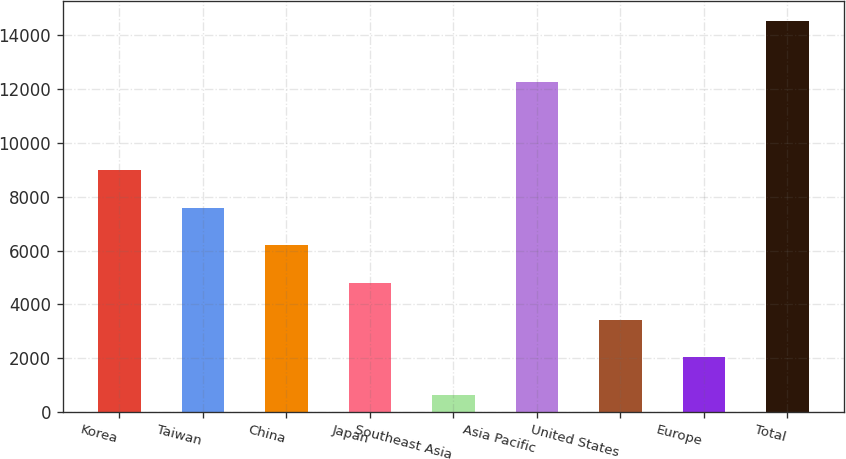<chart> <loc_0><loc_0><loc_500><loc_500><bar_chart><fcel>Korea<fcel>Taiwan<fcel>China<fcel>Japan<fcel>Southeast Asia<fcel>Asia Pacific<fcel>United States<fcel>Europe<fcel>Total<nl><fcel>8978.2<fcel>7588.5<fcel>6198.8<fcel>4809.1<fcel>640<fcel>12247<fcel>3419.4<fcel>2029.7<fcel>14537<nl></chart> 